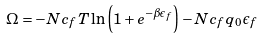<formula> <loc_0><loc_0><loc_500><loc_500>\Omega = - N c _ { f } T \ln \left ( 1 + e ^ { - \beta \epsilon _ { f } } \right ) - N c _ { f } q _ { 0 } \epsilon _ { f }</formula> 